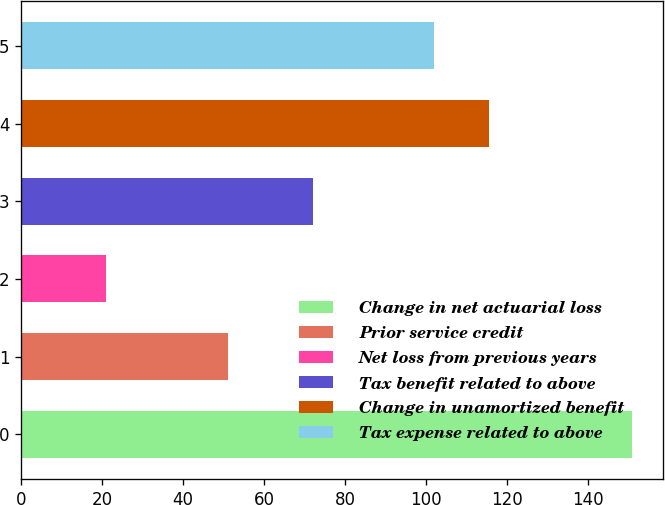<chart> <loc_0><loc_0><loc_500><loc_500><bar_chart><fcel>Change in net actuarial loss<fcel>Prior service credit<fcel>Net loss from previous years<fcel>Tax benefit related to above<fcel>Change in unamortized benefit<fcel>Tax expense related to above<nl><fcel>151<fcel>51<fcel>21<fcel>72<fcel>115.6<fcel>102<nl></chart> 